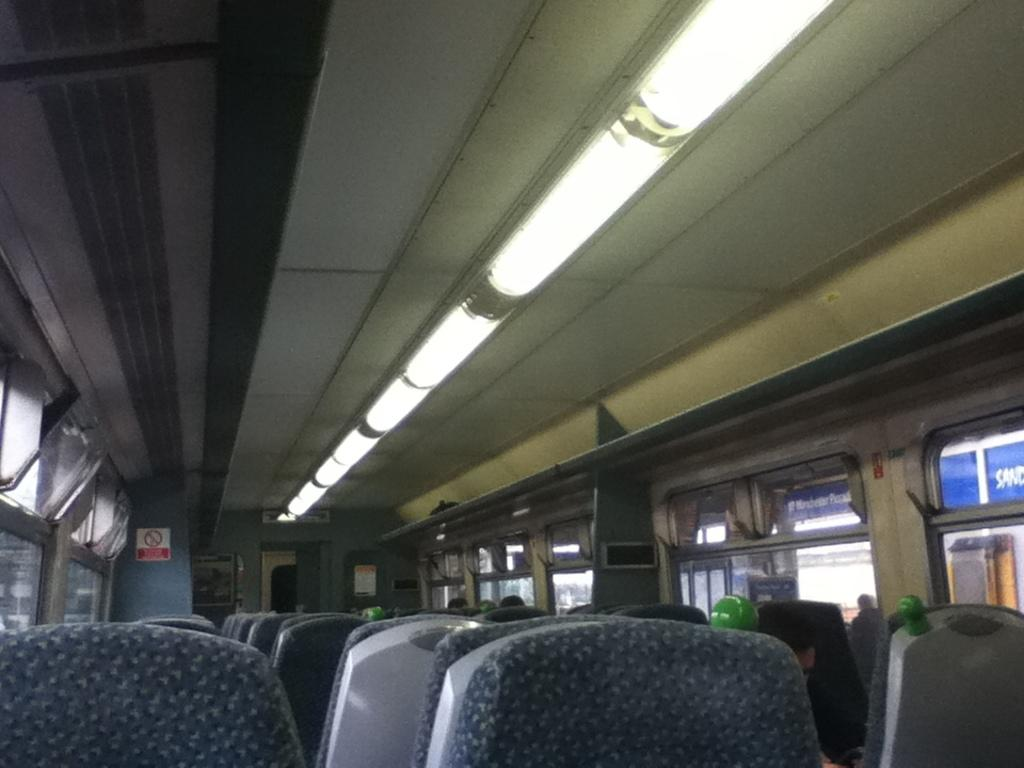Where was the image taken? The image was taken inside a bus. How are the seats arranged in the bus? The seats are arranged in a line in the bus. What can be found at the top of the bus? There are lights at the top of the bus. What allows passengers to see the outside while inside the bus? There are windows on either side of the bus. What type of clover is growing on the floor of the bus in the image? There is no clover present in the image; it is taken inside a bus with seats, lights, and windows. 